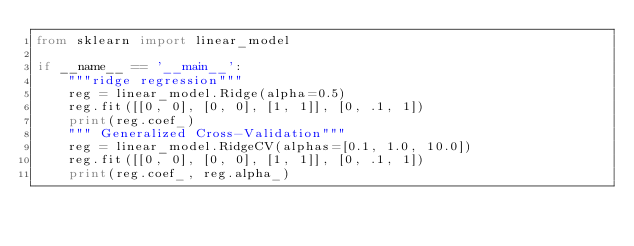Convert code to text. <code><loc_0><loc_0><loc_500><loc_500><_Python_>from sklearn import linear_model

if __name__ == '__main__':
    """ridge regression"""
    reg = linear_model.Ridge(alpha=0.5)
    reg.fit([[0, 0], [0, 0], [1, 1]], [0, .1, 1])
    print(reg.coef_)
    """ Generalized Cross-Validation"""
    reg = linear_model.RidgeCV(alphas=[0.1, 1.0, 10.0])
    reg.fit([[0, 0], [0, 0], [1, 1]], [0, .1, 1])
    print(reg.coef_, reg.alpha_)
</code> 